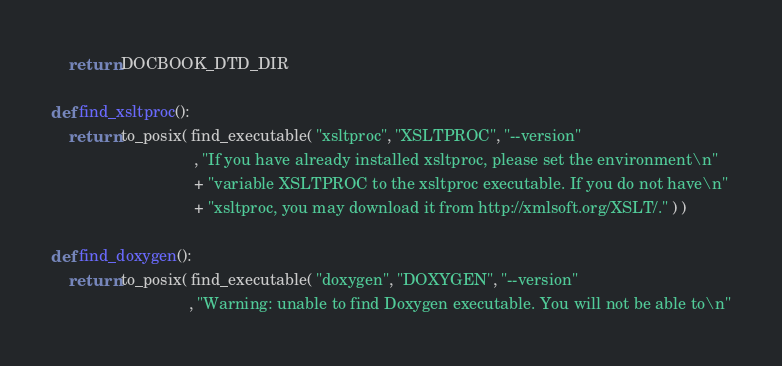Convert code to text. <code><loc_0><loc_0><loc_500><loc_500><_Python_>
    return DOCBOOK_DTD_DIR

def find_xsltproc():
    return to_posix( find_executable( "xsltproc", "XSLTPROC", "--version"
                                , "If you have already installed xsltproc, please set the environment\n"
                                + "variable XSLTPROC to the xsltproc executable. If you do not have\n"
                                + "xsltproc, you may download it from http://xmlsoft.org/XSLT/." ) )

def find_doxygen():
    return to_posix( find_executable( "doxygen", "DOXYGEN", "--version"
                               , "Warning: unable to find Doxygen executable. You will not be able to\n"</code> 